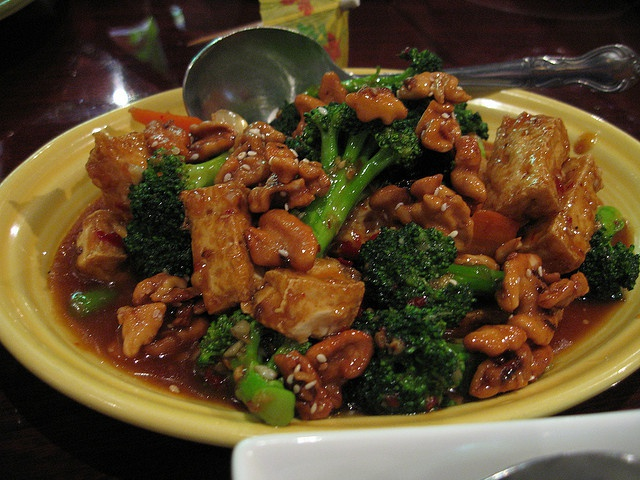Describe the objects in this image and their specific colors. I can see dining table in black, maroon, olive, and gray tones, broccoli in gray, black, darkgreen, and maroon tones, spoon in gray, black, and darkgreen tones, broccoli in gray, black, darkgreen, and maroon tones, and broccoli in gray, black, darkgreen, and maroon tones in this image. 